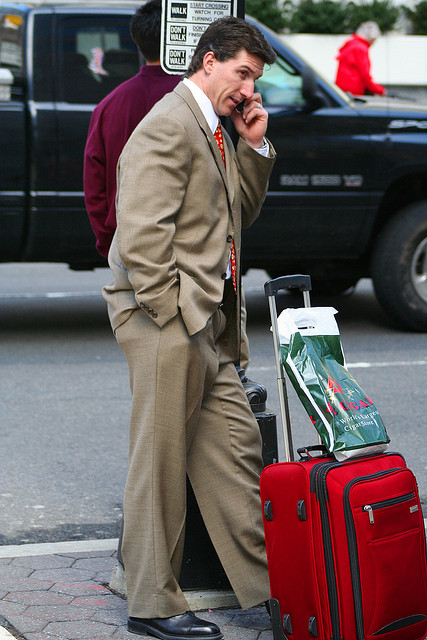<image>What kind of truck is beside the man? I don't know the specific kind of truck beside the man. It could possibly be a pickup, ram, dodge, or chevy. What kind of truck is beside the man? I don't know what kind of truck is beside the man. It can be a pickup, work truck, ram, dodge, chevy, or none. 